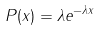<formula> <loc_0><loc_0><loc_500><loc_500>P ( x ) = \lambda e ^ { - \lambda x }</formula> 